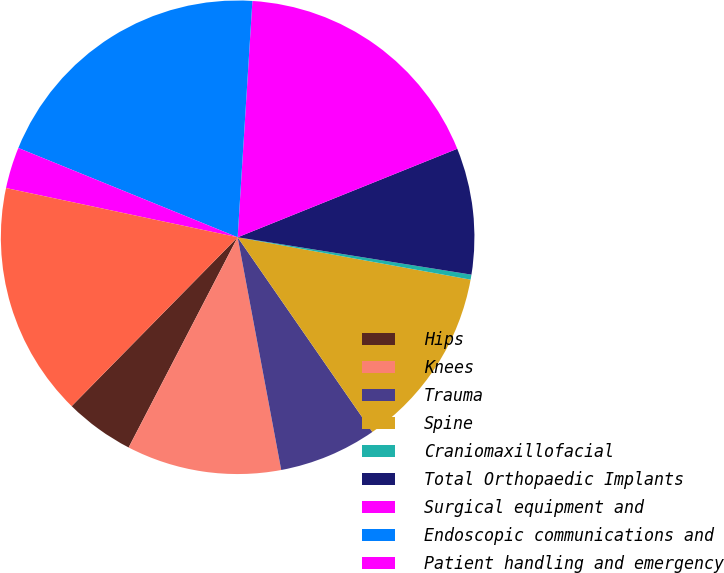<chart> <loc_0><loc_0><loc_500><loc_500><pie_chart><fcel>Hips<fcel>Knees<fcel>Trauma<fcel>Spine<fcel>Craniomaxillofacial<fcel>Total Orthopaedic Implants<fcel>Surgical equipment and<fcel>Endoscopic communications and<fcel>Patient handling and emergency<fcel>Total MedSurg Equipment<nl><fcel>4.75%<fcel>10.56%<fcel>6.69%<fcel>12.5%<fcel>0.34%<fcel>8.62%<fcel>17.91%<fcel>19.84%<fcel>2.82%<fcel>15.97%<nl></chart> 